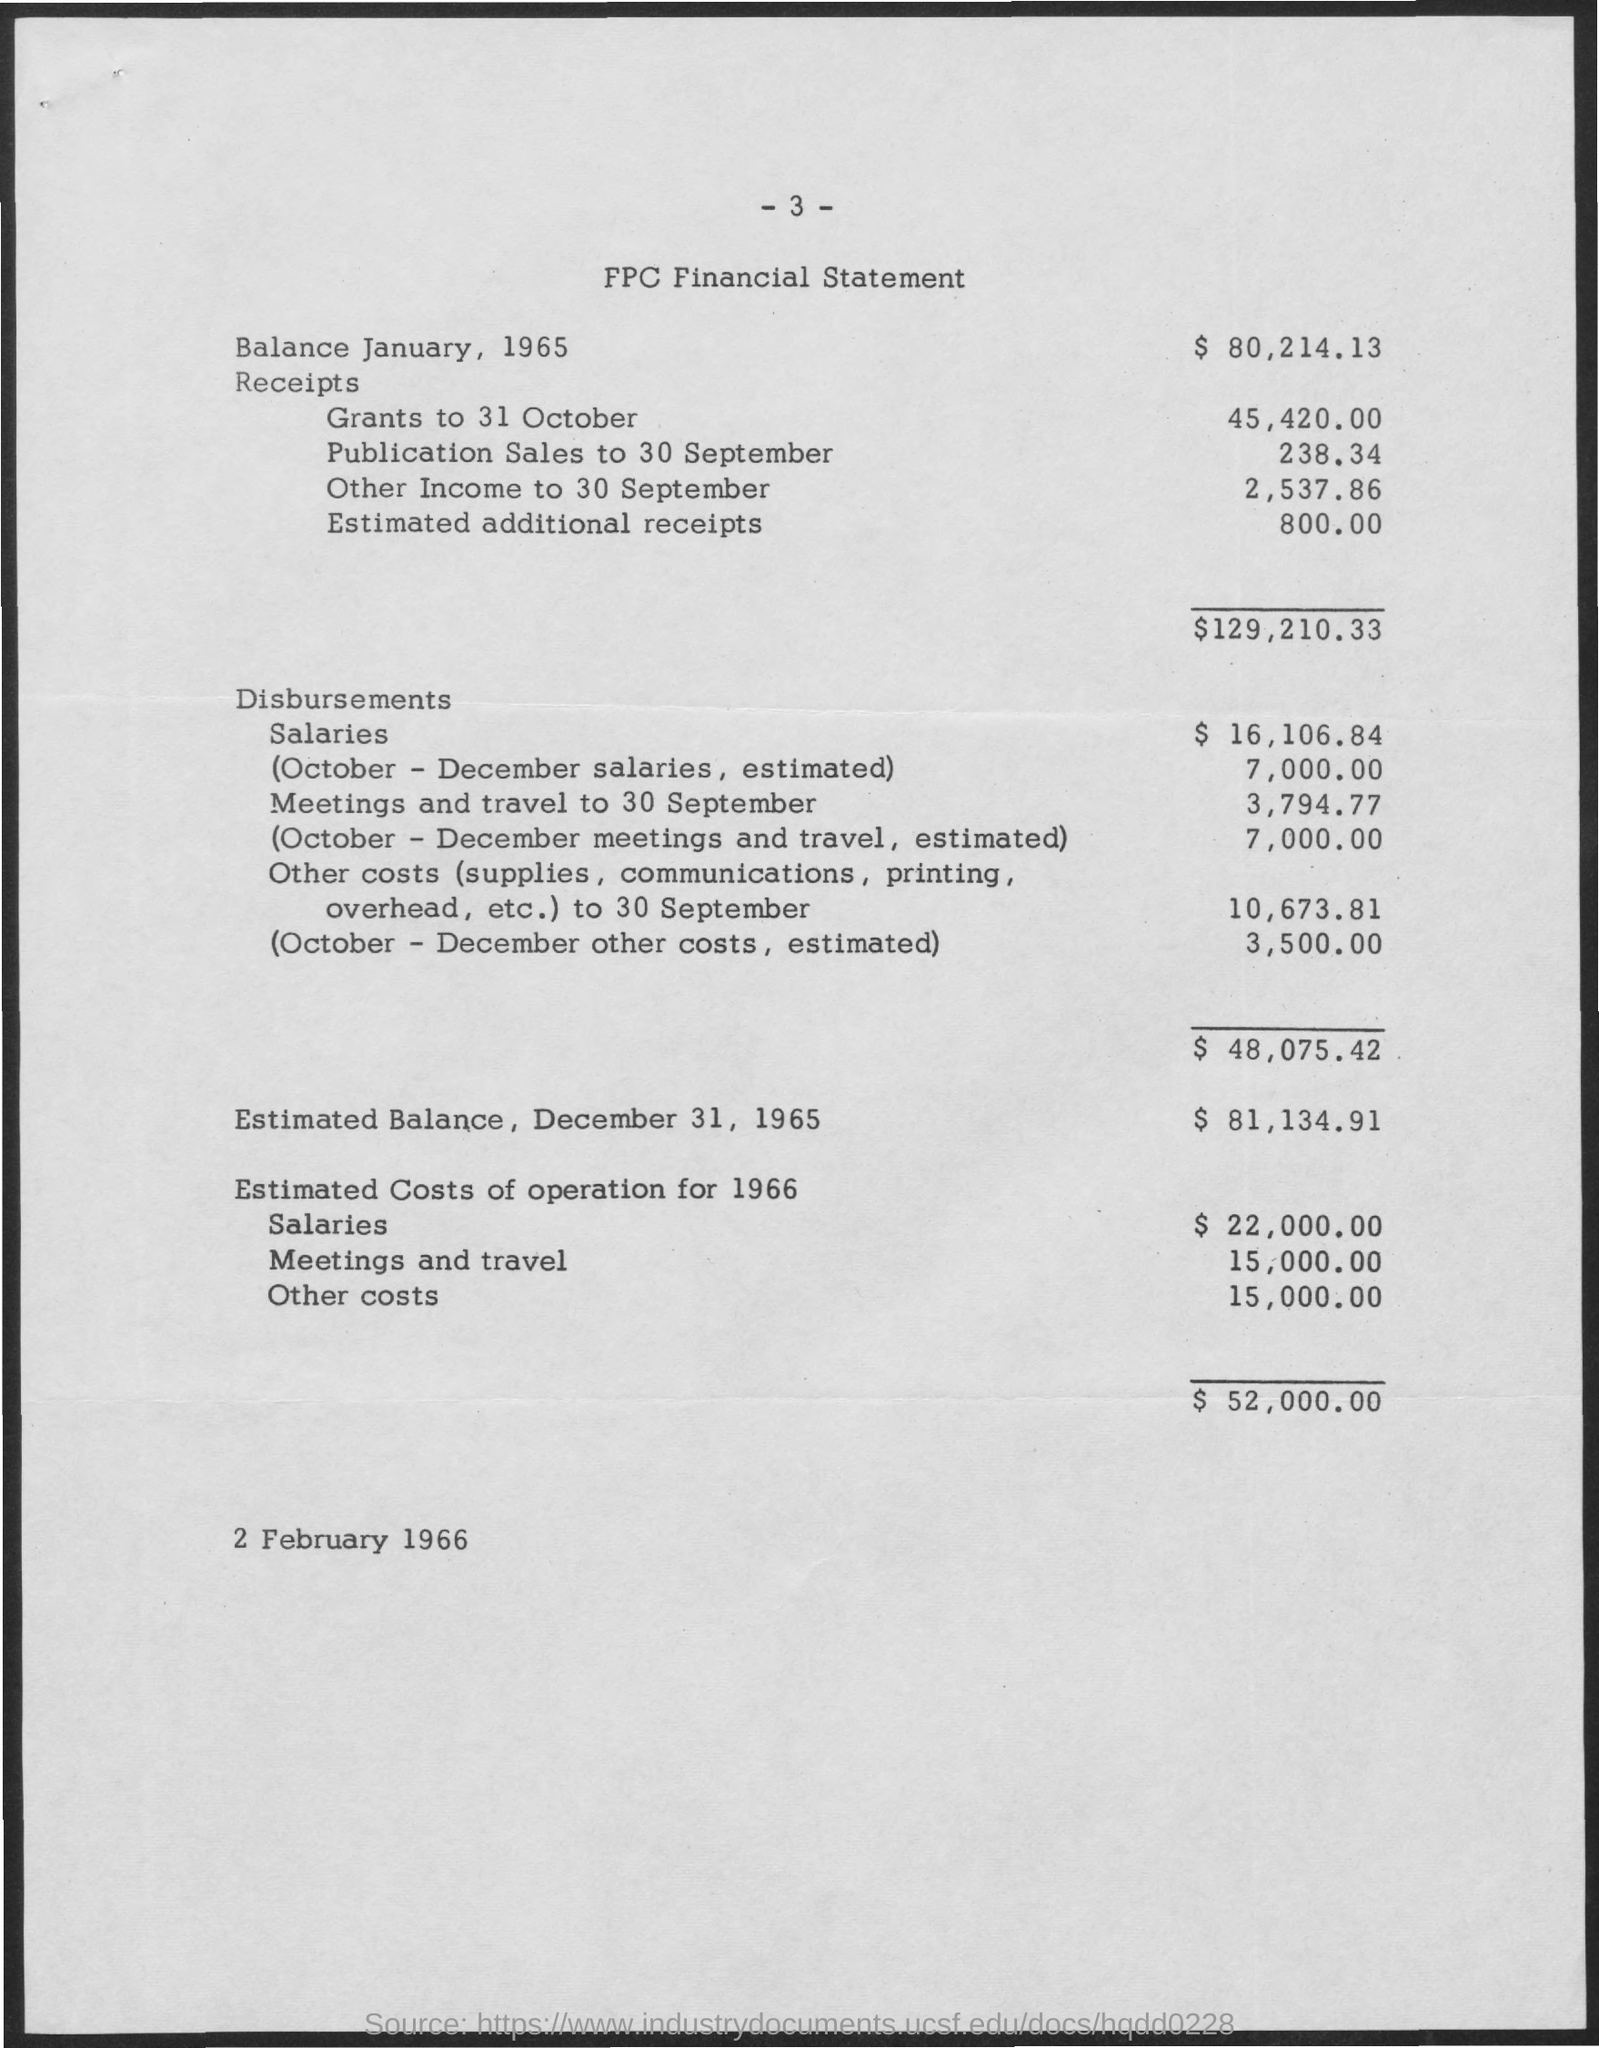What is the balance as of January,1965?
Make the answer very short. $ 80,214.13. What is the estimated balance as of December 31,1965?
Make the answer very short. $ 81,134.91. 